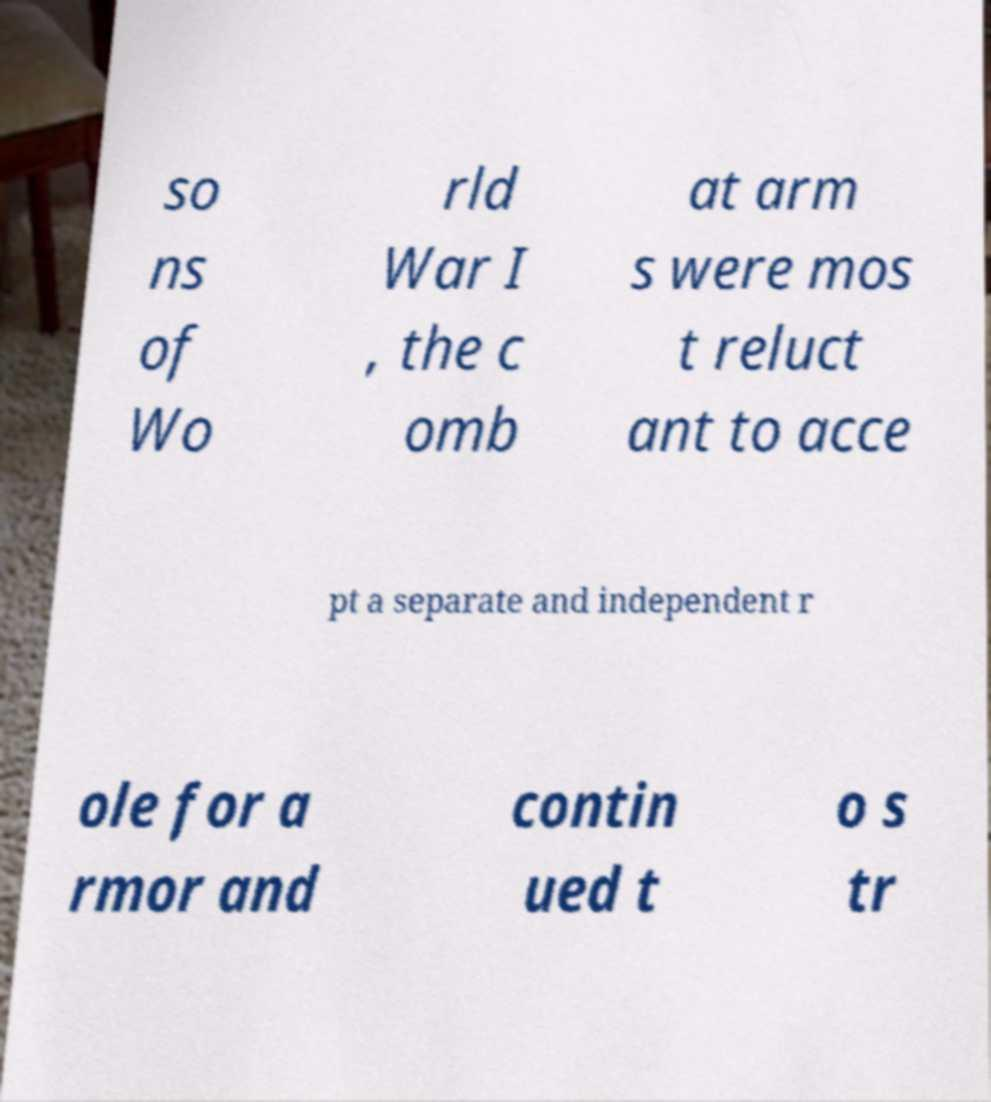For documentation purposes, I need the text within this image transcribed. Could you provide that? so ns of Wo rld War I , the c omb at arm s were mos t reluct ant to acce pt a separate and independent r ole for a rmor and contin ued t o s tr 